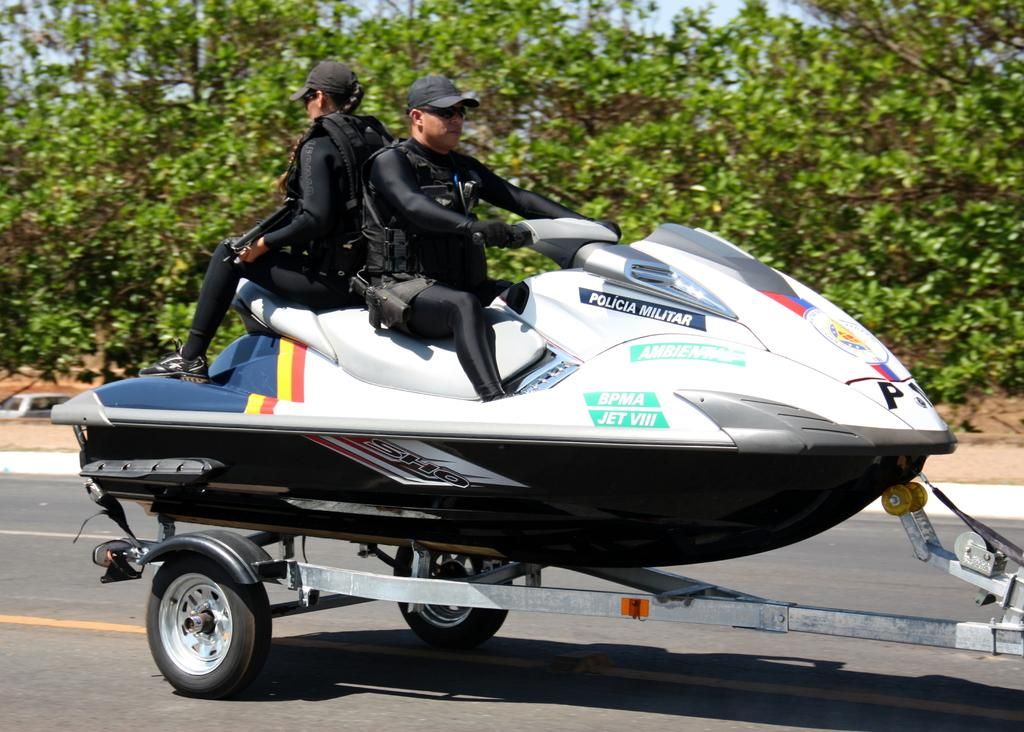How many people are in the image? There are two persons in the image. What are the two persons doing in the image? The two persons are sitting on a jet ski. What is the jet ski placed on in the image? The jet ski is on a wheel cart. Where is the wheel cart located in the image? There is a wheel cart on the road in the image. What can be seen in the background of the image? Trees and the sky are visible in the background of the image. What type of design is featured on the town's flag in the image? There is no town or flag present in the image; it features two persons sitting on a jet ski on a wheel cart. 